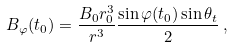Convert formula to latex. <formula><loc_0><loc_0><loc_500><loc_500>B _ { \varphi } ( t _ { 0 } ) = \frac { B _ { 0 } r _ { 0 } ^ { 3 } } { r ^ { 3 } } \frac { \sin \varphi ( t _ { 0 } ) \sin \theta _ { t } } { 2 } \, ,</formula> 